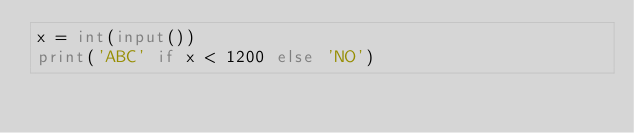<code> <loc_0><loc_0><loc_500><loc_500><_Python_>x = int(input())
print('ABC' if x < 1200 else 'NO')</code> 